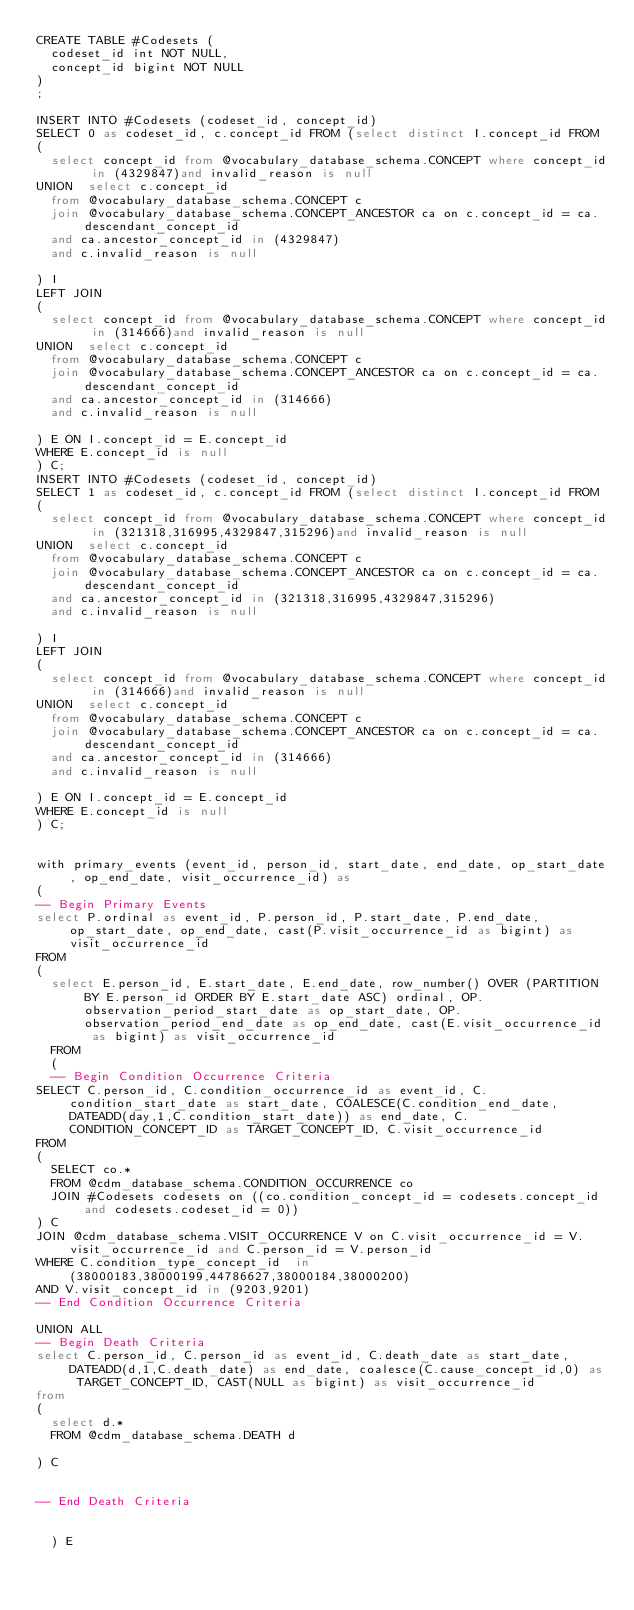<code> <loc_0><loc_0><loc_500><loc_500><_SQL_>CREATE TABLE #Codesets (
  codeset_id int NOT NULL,
  concept_id bigint NOT NULL
)
;

INSERT INTO #Codesets (codeset_id, concept_id)
SELECT 0 as codeset_id, c.concept_id FROM (select distinct I.concept_id FROM
( 
  select concept_id from @vocabulary_database_schema.CONCEPT where concept_id in (4329847)and invalid_reason is null
UNION  select c.concept_id
  from @vocabulary_database_schema.CONCEPT c
  join @vocabulary_database_schema.CONCEPT_ANCESTOR ca on c.concept_id = ca.descendant_concept_id
  and ca.ancestor_concept_id in (4329847)
  and c.invalid_reason is null

) I
LEFT JOIN
(
  select concept_id from @vocabulary_database_schema.CONCEPT where concept_id in (314666)and invalid_reason is null
UNION  select c.concept_id
  from @vocabulary_database_schema.CONCEPT c
  join @vocabulary_database_schema.CONCEPT_ANCESTOR ca on c.concept_id = ca.descendant_concept_id
  and ca.ancestor_concept_id in (314666)
  and c.invalid_reason is null

) E ON I.concept_id = E.concept_id
WHERE E.concept_id is null
) C;
INSERT INTO #Codesets (codeset_id, concept_id)
SELECT 1 as codeset_id, c.concept_id FROM (select distinct I.concept_id FROM
( 
  select concept_id from @vocabulary_database_schema.CONCEPT where concept_id in (321318,316995,4329847,315296)and invalid_reason is null
UNION  select c.concept_id
  from @vocabulary_database_schema.CONCEPT c
  join @vocabulary_database_schema.CONCEPT_ANCESTOR ca on c.concept_id = ca.descendant_concept_id
  and ca.ancestor_concept_id in (321318,316995,4329847,315296)
  and c.invalid_reason is null

) I
LEFT JOIN
(
  select concept_id from @vocabulary_database_schema.CONCEPT where concept_id in (314666)and invalid_reason is null
UNION  select c.concept_id
  from @vocabulary_database_schema.CONCEPT c
  join @vocabulary_database_schema.CONCEPT_ANCESTOR ca on c.concept_id = ca.descendant_concept_id
  and ca.ancestor_concept_id in (314666)
  and c.invalid_reason is null

) E ON I.concept_id = E.concept_id
WHERE E.concept_id is null
) C;


with primary_events (event_id, person_id, start_date, end_date, op_start_date, op_end_date, visit_occurrence_id) as
(
-- Begin Primary Events
select P.ordinal as event_id, P.person_id, P.start_date, P.end_date, op_start_date, op_end_date, cast(P.visit_occurrence_id as bigint) as visit_occurrence_id
FROM
(
  select E.person_id, E.start_date, E.end_date, row_number() OVER (PARTITION BY E.person_id ORDER BY E.start_date ASC) ordinal, OP.observation_period_start_date as op_start_date, OP.observation_period_end_date as op_end_date, cast(E.visit_occurrence_id as bigint) as visit_occurrence_id
  FROM 
  (
  -- Begin Condition Occurrence Criteria
SELECT C.person_id, C.condition_occurrence_id as event_id, C.condition_start_date as start_date, COALESCE(C.condition_end_date, DATEADD(day,1,C.condition_start_date)) as end_date, C.CONDITION_CONCEPT_ID as TARGET_CONCEPT_ID, C.visit_occurrence_id
FROM 
(
  SELECT co.* 
  FROM @cdm_database_schema.CONDITION_OCCURRENCE co
  JOIN #Codesets codesets on ((co.condition_concept_id = codesets.concept_id and codesets.codeset_id = 0))
) C
JOIN @cdm_database_schema.VISIT_OCCURRENCE V on C.visit_occurrence_id = V.visit_occurrence_id and C.person_id = V.person_id
WHERE C.condition_type_concept_id  in (38000183,38000199,44786627,38000184,38000200)
AND V.visit_concept_id in (9203,9201)
-- End Condition Occurrence Criteria

UNION ALL
-- Begin Death Criteria
select C.person_id, C.person_id as event_id, C.death_date as start_date, DATEADD(d,1,C.death_date) as end_date, coalesce(C.cause_concept_id,0) as TARGET_CONCEPT_ID, CAST(NULL as bigint) as visit_occurrence_id
from 
(
  select d.*
  FROM @cdm_database_schema.DEATH d

) C


-- End Death Criteria


  ) E</code> 